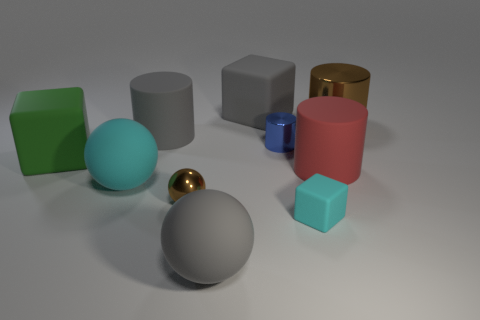Subtract all spheres. How many objects are left? 7 Add 4 big brown cylinders. How many big brown cylinders are left? 5 Add 2 small metal balls. How many small metal balls exist? 3 Subtract 0 brown blocks. How many objects are left? 10 Subtract all rubber balls. Subtract all small cyan matte blocks. How many objects are left? 7 